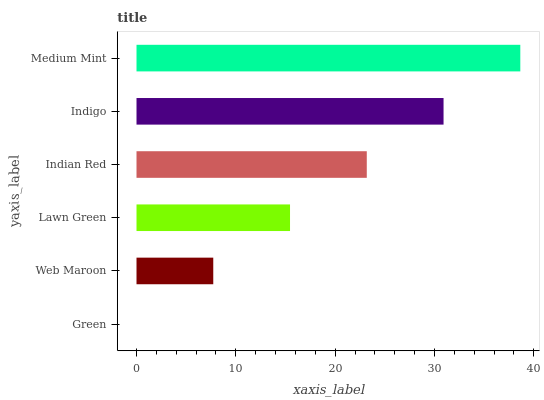Is Green the minimum?
Answer yes or no. Yes. Is Medium Mint the maximum?
Answer yes or no. Yes. Is Web Maroon the minimum?
Answer yes or no. No. Is Web Maroon the maximum?
Answer yes or no. No. Is Web Maroon greater than Green?
Answer yes or no. Yes. Is Green less than Web Maroon?
Answer yes or no. Yes. Is Green greater than Web Maroon?
Answer yes or no. No. Is Web Maroon less than Green?
Answer yes or no. No. Is Indian Red the high median?
Answer yes or no. Yes. Is Lawn Green the low median?
Answer yes or no. Yes. Is Medium Mint the high median?
Answer yes or no. No. Is Indian Red the low median?
Answer yes or no. No. 